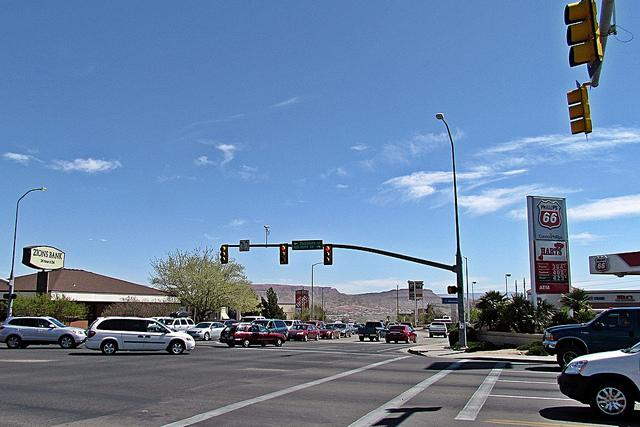What type of station is nearby?

Choices:
A) gas
B) bus
C) fire
D) train gas 